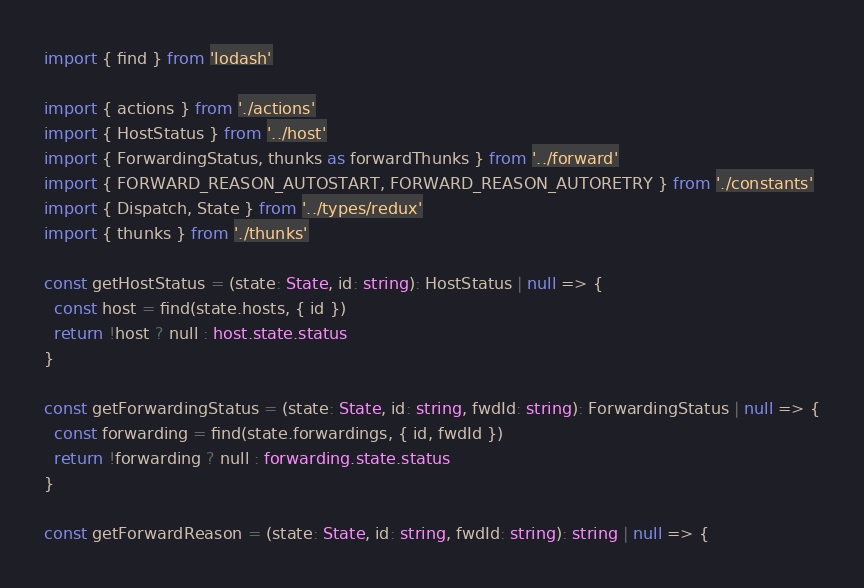<code> <loc_0><loc_0><loc_500><loc_500><_TypeScript_>import { find } from 'lodash'

import { actions } from './actions'
import { HostStatus } from '../host'
import { ForwardingStatus, thunks as forwardThunks } from '../forward'
import { FORWARD_REASON_AUTOSTART, FORWARD_REASON_AUTORETRY } from './constants'
import { Dispatch, State } from '../types/redux'
import { thunks } from './thunks'

const getHostStatus = (state: State, id: string): HostStatus | null => {
  const host = find(state.hosts, { id })
  return !host ? null : host.state.status
}

const getForwardingStatus = (state: State, id: string, fwdId: string): ForwardingStatus | null => {
  const forwarding = find(state.forwardings, { id, fwdId })
  return !forwarding ? null : forwarding.state.status
}

const getForwardReason = (state: State, id: string, fwdId: string): string | null => {</code> 